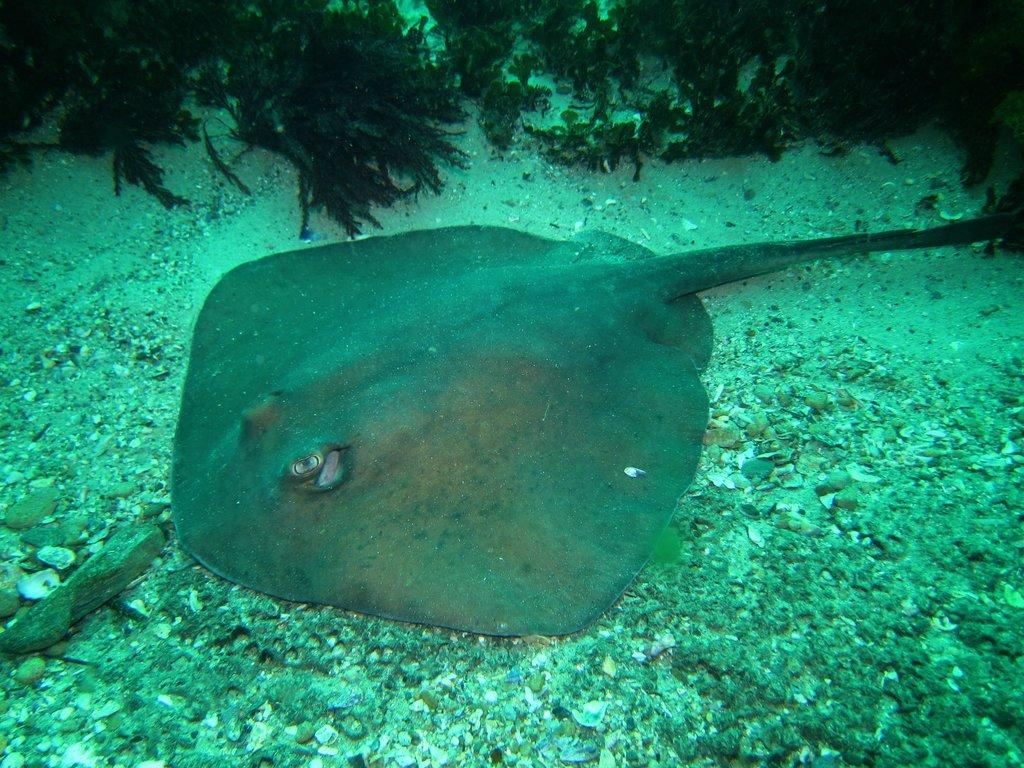What type of fish can be seen in the image? There are skate fish in the image. What other objects or elements are present in the image? There are stones and water plants in the image. Where are these elements located? All of these elements are underwater. What type of wool can be seen in the image? There is no wool present in the image; it is an underwater scene featuring skate fish, stones, and water plants. 